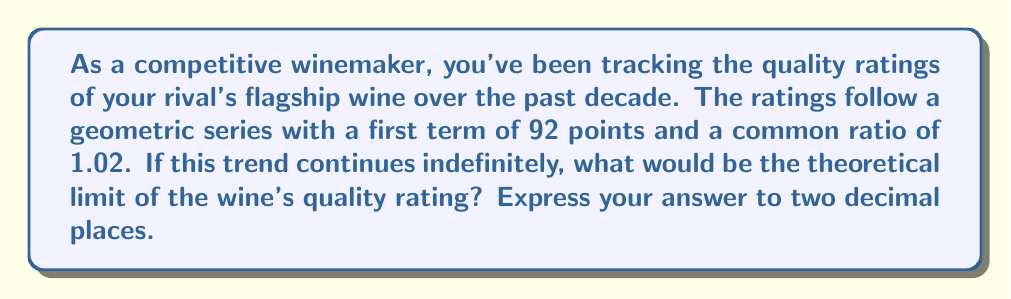Can you answer this question? Let's approach this step-by-step:

1) We're dealing with a geometric series where:
   $a = 92$ (first term)
   $r = 1.02$ (common ratio)

2) For a geometric series, the sum to infinity (S∞) is given by the formula:
   $$S_∞ = \frac{a}{1-r}$$
   This formula is valid when $|r| < 1$

3) However, in our case, $r > 1$. This means the series is divergent and doesn't have a finite sum to infinity.

4) But we're not looking for the sum. We're interested in the limit of the terms themselves.

5) For a geometric sequence, the nth term is given by:
   $$a_n = ar^{n-1}$$

6) As n approaches infinity, this becomes:
   $$\lim_{n \to \infty} a_n = \lim_{n \to \infty} ar^{n-1}$$

7) Since $r > 1$, this limit doesn't exist (it grows without bound).

8) However, in the context of wine ratings, there's a practical upper limit of 100 points in most rating systems.

9) To find when the series would theoretically reach 100 points, we can solve:
   $$92 * 1.02^{n-1} = 100$$

10) Taking logarithms of both sides:
    $$\log(92) + (n-1)\log(1.02) = \log(100)$$

11) Solving for n:
    $$n = \frac{\log(100) - \log(92)}{\log(1.02)} + 1 \approx 45.67$$

12) This means the rating would theoretically reach 100 points after about 46 years.

Therefore, while mathematically the series doesn't converge, in the practical context of wine ratings, it would converge to 100.00 points.
Answer: 100.00 points 